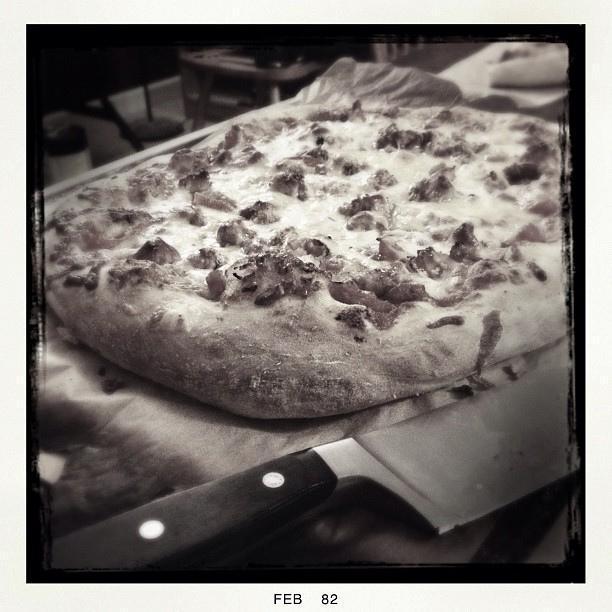Is the given caption "The knife is under the pizza." fitting for the image?
Answer yes or no. No. 